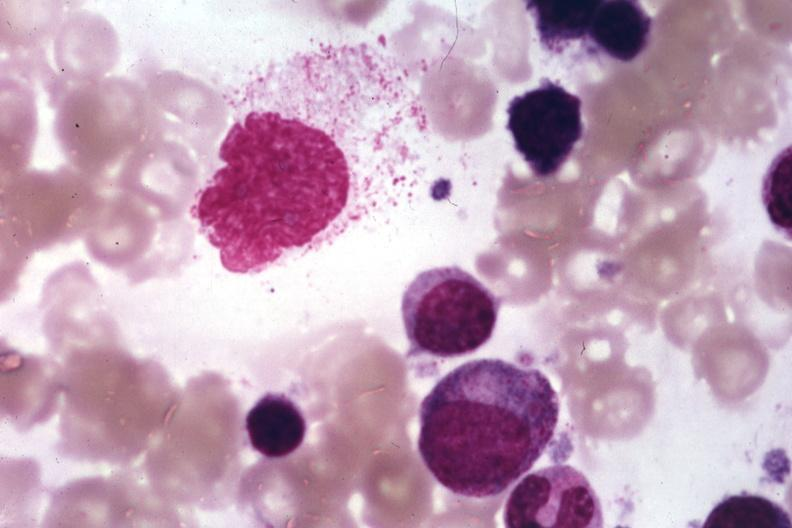what is present?
Answer the question using a single word or phrase. Histiocyte 